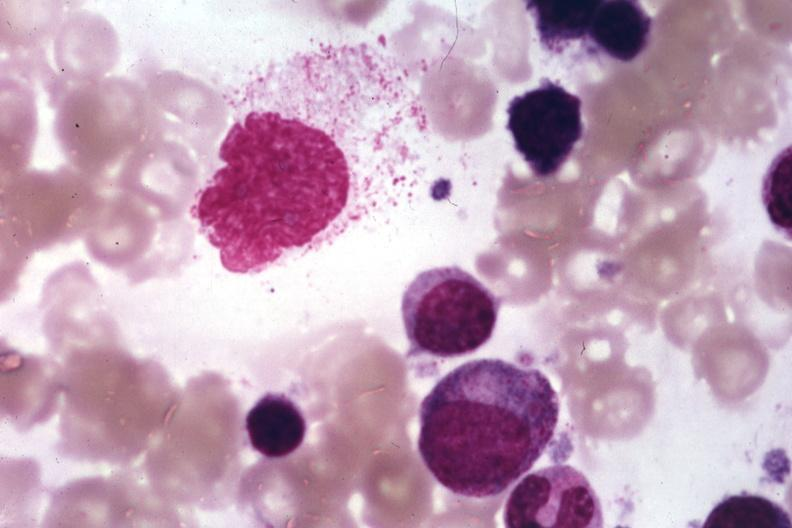what is present?
Answer the question using a single word or phrase. Histiocyte 